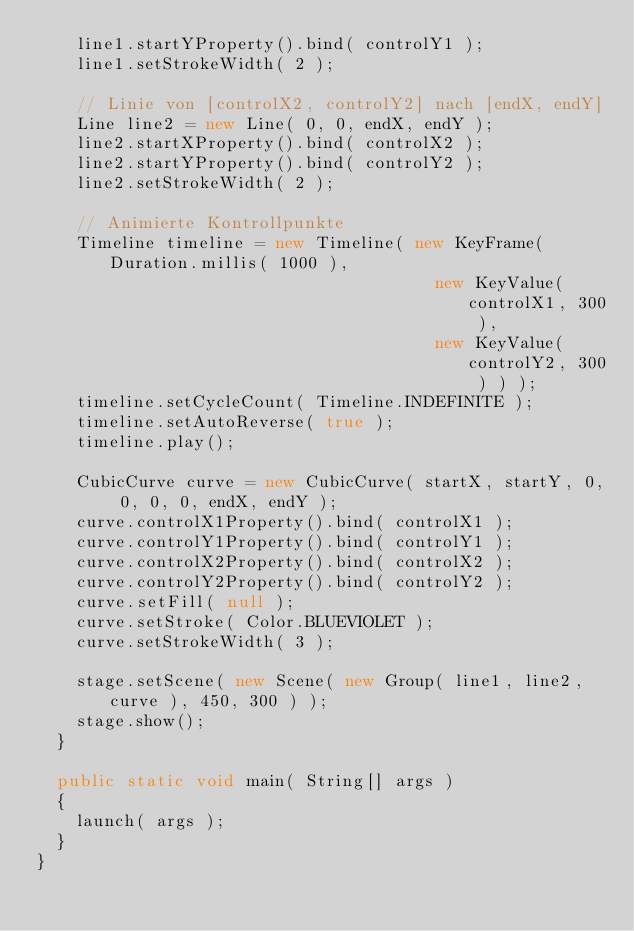Convert code to text. <code><loc_0><loc_0><loc_500><loc_500><_Java_>    line1.startYProperty().bind( controlY1 );
    line1.setStrokeWidth( 2 );

    // Linie von [controlX2, controlY2] nach [endX, endY]
    Line line2 = new Line( 0, 0, endX, endY );
    line2.startXProperty().bind( controlX2 );
    line2.startYProperty().bind( controlY2 );
    line2.setStrokeWidth( 2 );

    // Animierte Kontrollpunkte
    Timeline timeline = new Timeline( new KeyFrame( Duration.millis( 1000 ),
                                        new KeyValue( controlX1, 300 ),
                                        new KeyValue( controlY2, 300 ) ) );
    timeline.setCycleCount( Timeline.INDEFINITE );
    timeline.setAutoReverse( true );
    timeline.play();

    CubicCurve curve = new CubicCurve( startX, startY, 0, 0, 0, 0, endX, endY );
    curve.controlX1Property().bind( controlX1 );
    curve.controlY1Property().bind( controlY1 );
    curve.controlX2Property().bind( controlX2 );
    curve.controlY2Property().bind( controlY2 );
    curve.setFill( null );
    curve.setStroke( Color.BLUEVIOLET );
    curve.setStrokeWidth( 3 );

    stage.setScene( new Scene( new Group( line1, line2, curve ), 450, 300 ) );
    stage.show();
  }

  public static void main( String[] args )
  {
    launch( args );
  }
}</code> 